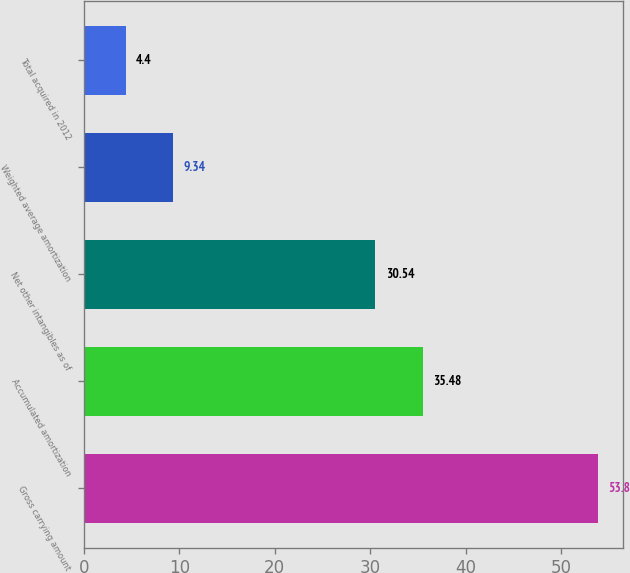Convert chart to OTSL. <chart><loc_0><loc_0><loc_500><loc_500><bar_chart><fcel>Gross carrying amount<fcel>Accumulated amortization<fcel>Net other intangibles as of<fcel>Weighted average amortization<fcel>Total acquired in 2012<nl><fcel>53.8<fcel>35.48<fcel>30.54<fcel>9.34<fcel>4.4<nl></chart> 